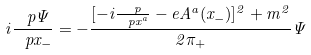<formula> <loc_0><loc_0><loc_500><loc_500>i \frac { \ p \Psi } { \ p x _ { - } } = - \frac { [ - i \frac { \ p } { \ p x ^ { a } } - e A ^ { a } ( x _ { - } ) ] ^ { 2 } + m ^ { 2 } } { 2 \pi _ { + } } \Psi</formula> 